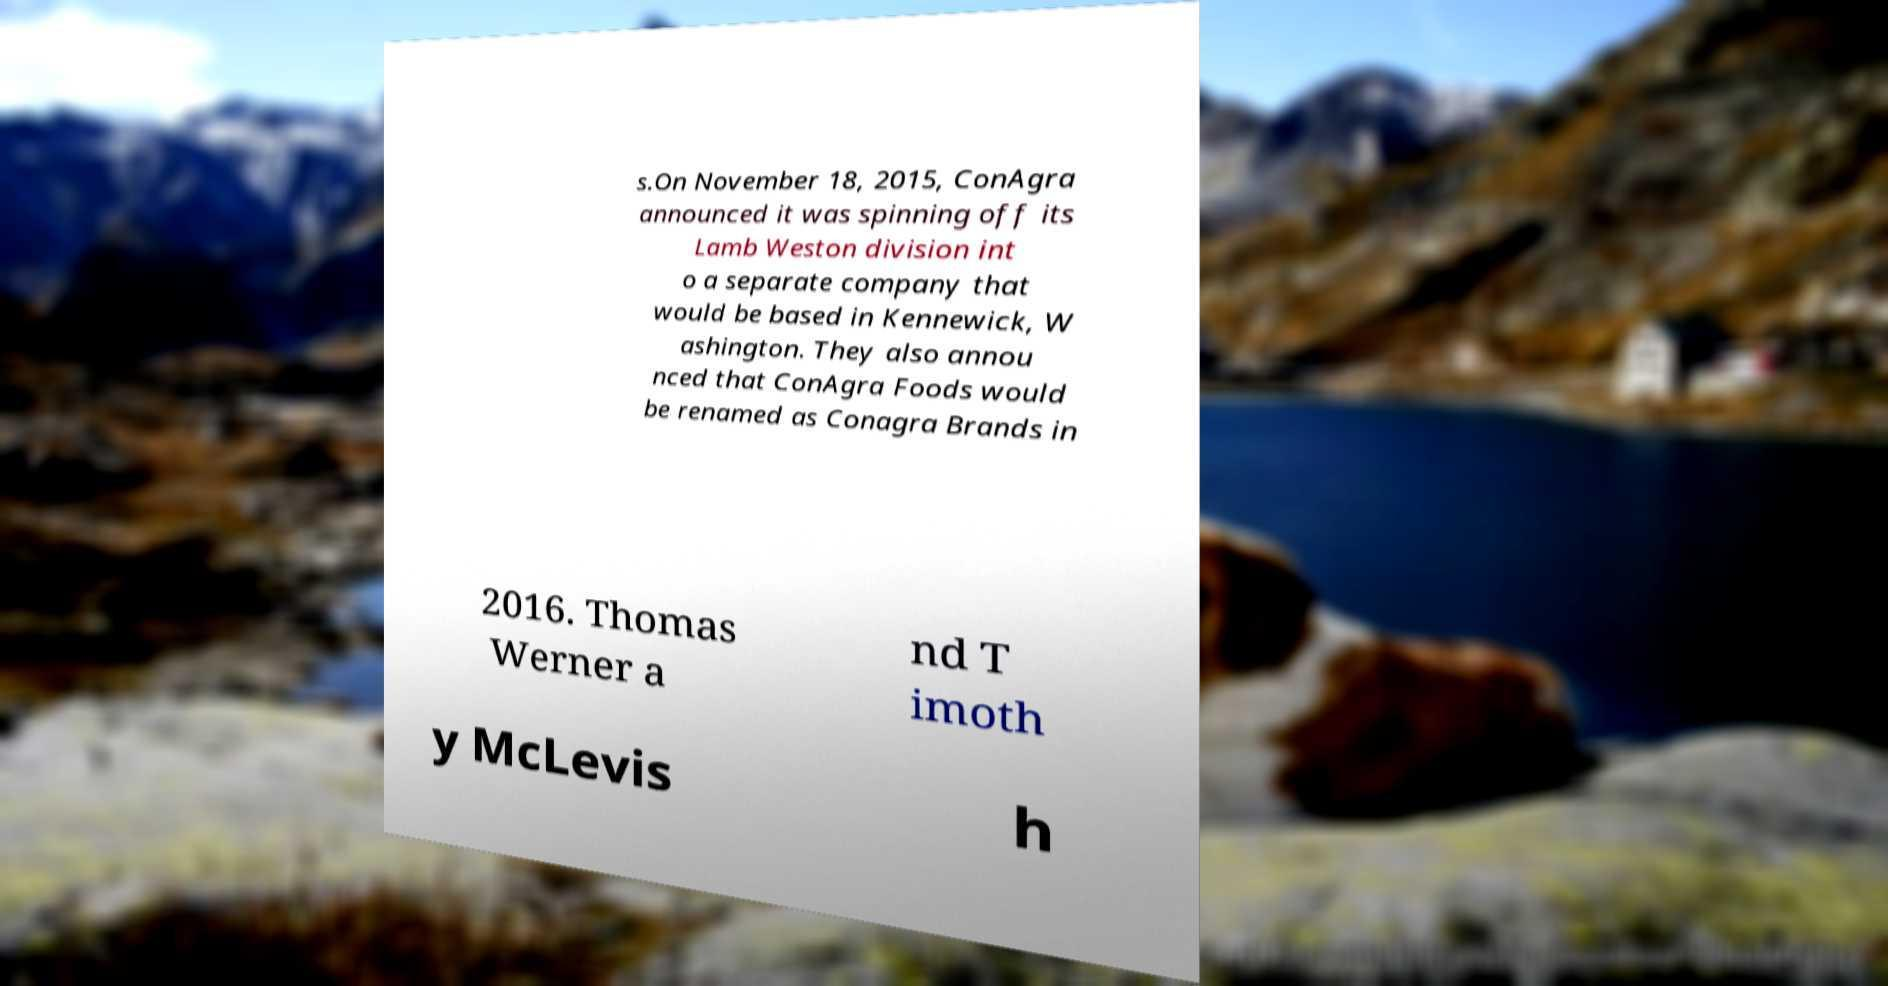Could you assist in decoding the text presented in this image and type it out clearly? s.On November 18, 2015, ConAgra announced it was spinning off its Lamb Weston division int o a separate company that would be based in Kennewick, W ashington. They also annou nced that ConAgra Foods would be renamed as Conagra Brands in 2016. Thomas Werner a nd T imoth y McLevis h 